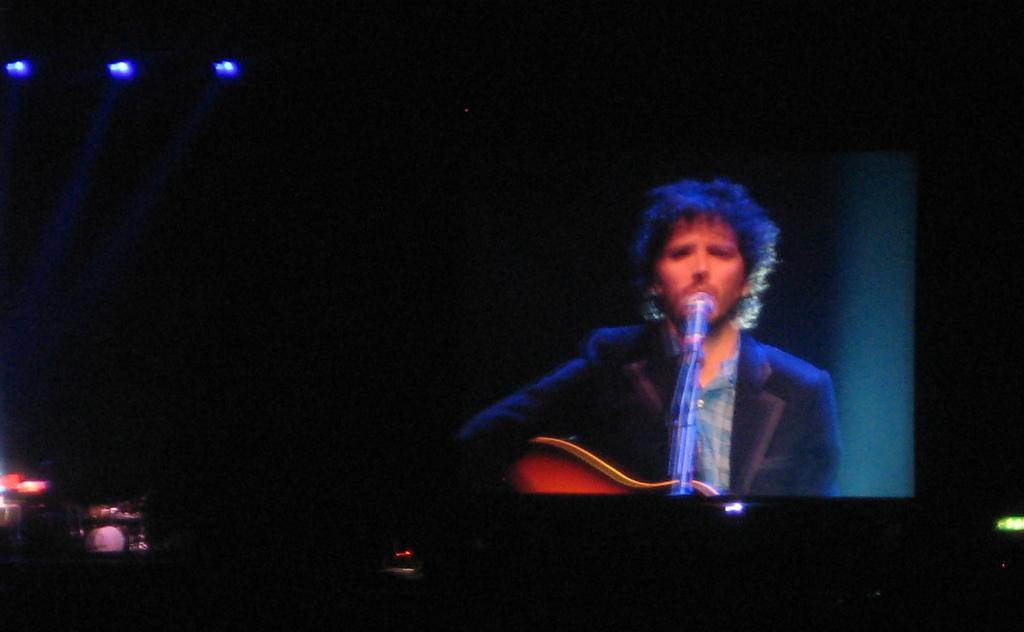Describe this image in one or two sentences. In this image I can see a man, a mic and brown colour guitar. I can see he is wearing shirt and blazer. I can see few lights over here and I can see this image is little bit in dark. 